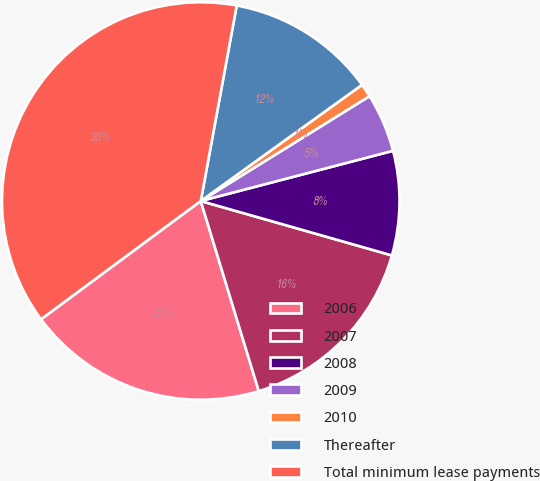Convert chart to OTSL. <chart><loc_0><loc_0><loc_500><loc_500><pie_chart><fcel>2006<fcel>2007<fcel>2008<fcel>2009<fcel>2010<fcel>Thereafter<fcel>Total minimum lease payments<nl><fcel>19.57%<fcel>15.87%<fcel>8.48%<fcel>4.78%<fcel>1.09%<fcel>12.17%<fcel>38.04%<nl></chart> 